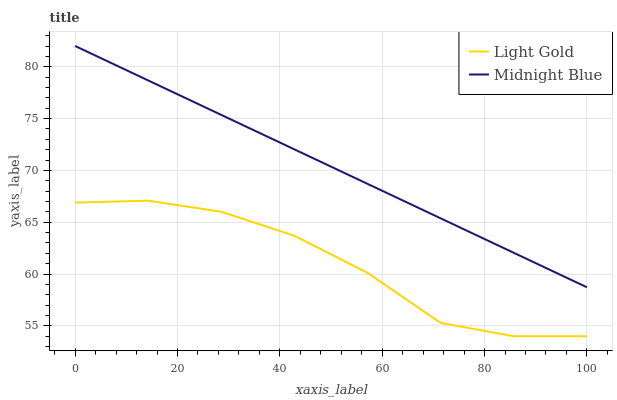Does Light Gold have the minimum area under the curve?
Answer yes or no. Yes. Does Midnight Blue have the maximum area under the curve?
Answer yes or no. Yes. Does Midnight Blue have the minimum area under the curve?
Answer yes or no. No. Is Midnight Blue the smoothest?
Answer yes or no. Yes. Is Light Gold the roughest?
Answer yes or no. Yes. Is Midnight Blue the roughest?
Answer yes or no. No. Does Light Gold have the lowest value?
Answer yes or no. Yes. Does Midnight Blue have the lowest value?
Answer yes or no. No. Does Midnight Blue have the highest value?
Answer yes or no. Yes. Is Light Gold less than Midnight Blue?
Answer yes or no. Yes. Is Midnight Blue greater than Light Gold?
Answer yes or no. Yes. Does Light Gold intersect Midnight Blue?
Answer yes or no. No. 